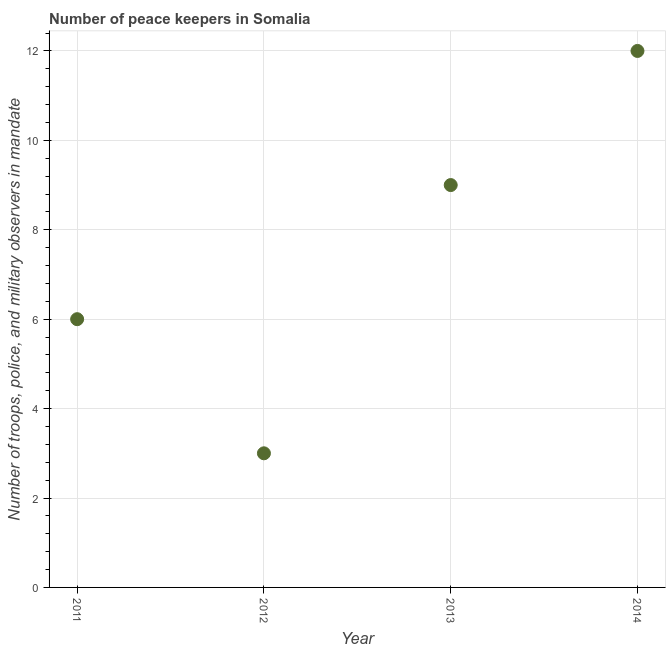What is the number of peace keepers in 2011?
Provide a short and direct response. 6. Across all years, what is the maximum number of peace keepers?
Keep it short and to the point. 12. Across all years, what is the minimum number of peace keepers?
Give a very brief answer. 3. In which year was the number of peace keepers maximum?
Keep it short and to the point. 2014. What is the sum of the number of peace keepers?
Make the answer very short. 30. What is the difference between the number of peace keepers in 2011 and 2012?
Offer a terse response. 3. What is the average number of peace keepers per year?
Your answer should be very brief. 7.5. In how many years, is the number of peace keepers greater than 0.8 ?
Keep it short and to the point. 4. Do a majority of the years between 2011 and 2013 (inclusive) have number of peace keepers greater than 2 ?
Your answer should be compact. Yes. What is the ratio of the number of peace keepers in 2012 to that in 2013?
Ensure brevity in your answer.  0.33. What is the difference between the highest and the lowest number of peace keepers?
Give a very brief answer. 9. In how many years, is the number of peace keepers greater than the average number of peace keepers taken over all years?
Give a very brief answer. 2. Does the number of peace keepers monotonically increase over the years?
Your answer should be very brief. No. How many dotlines are there?
Give a very brief answer. 1. What is the difference between two consecutive major ticks on the Y-axis?
Give a very brief answer. 2. Are the values on the major ticks of Y-axis written in scientific E-notation?
Give a very brief answer. No. Does the graph contain any zero values?
Offer a terse response. No. What is the title of the graph?
Keep it short and to the point. Number of peace keepers in Somalia. What is the label or title of the Y-axis?
Your response must be concise. Number of troops, police, and military observers in mandate. What is the Number of troops, police, and military observers in mandate in 2011?
Give a very brief answer. 6. What is the Number of troops, police, and military observers in mandate in 2012?
Offer a terse response. 3. What is the Number of troops, police, and military observers in mandate in 2013?
Your response must be concise. 9. What is the difference between the Number of troops, police, and military observers in mandate in 2011 and 2012?
Offer a very short reply. 3. What is the difference between the Number of troops, police, and military observers in mandate in 2011 and 2013?
Give a very brief answer. -3. What is the difference between the Number of troops, police, and military observers in mandate in 2011 and 2014?
Give a very brief answer. -6. What is the ratio of the Number of troops, police, and military observers in mandate in 2011 to that in 2012?
Your answer should be very brief. 2. What is the ratio of the Number of troops, police, and military observers in mandate in 2011 to that in 2013?
Provide a succinct answer. 0.67. What is the ratio of the Number of troops, police, and military observers in mandate in 2012 to that in 2013?
Your answer should be very brief. 0.33. 